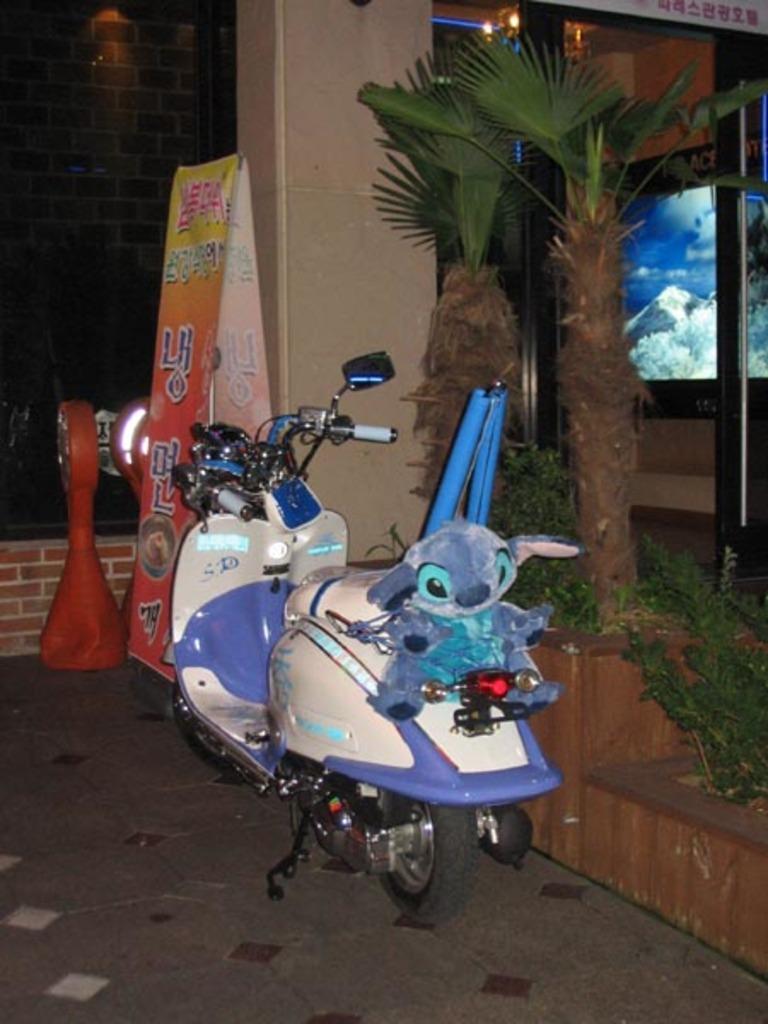Could you give a brief overview of what you see in this image? In this image I can see the bike which is in cream and blue color. I can also see the blue color toy on the bike. To the side I can see the plants. In the background I can see the banner, orange color object and the building. 